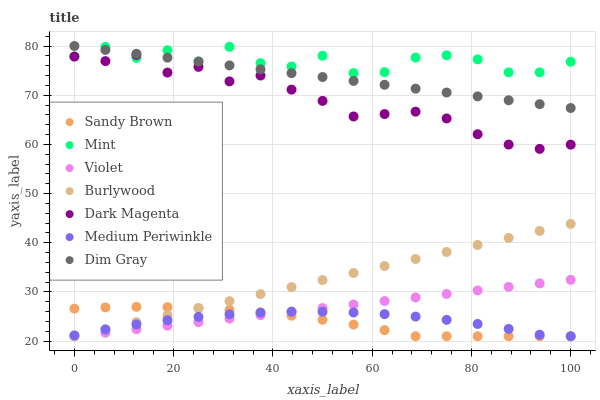Does Sandy Brown have the minimum area under the curve?
Answer yes or no. Yes. Does Mint have the maximum area under the curve?
Answer yes or no. Yes. Does Dark Magenta have the minimum area under the curve?
Answer yes or no. No. Does Dark Magenta have the maximum area under the curve?
Answer yes or no. No. Is Violet the smoothest?
Answer yes or no. Yes. Is Mint the roughest?
Answer yes or no. Yes. Is Dark Magenta the smoothest?
Answer yes or no. No. Is Dark Magenta the roughest?
Answer yes or no. No. Does Burlywood have the lowest value?
Answer yes or no. Yes. Does Dark Magenta have the lowest value?
Answer yes or no. No. Does Dim Gray have the highest value?
Answer yes or no. Yes. Does Dark Magenta have the highest value?
Answer yes or no. No. Is Sandy Brown less than Dim Gray?
Answer yes or no. Yes. Is Dark Magenta greater than Medium Periwinkle?
Answer yes or no. Yes. Does Medium Periwinkle intersect Burlywood?
Answer yes or no. Yes. Is Medium Periwinkle less than Burlywood?
Answer yes or no. No. Is Medium Periwinkle greater than Burlywood?
Answer yes or no. No. Does Sandy Brown intersect Dim Gray?
Answer yes or no. No. 